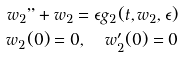<formula> <loc_0><loc_0><loc_500><loc_500>w _ { 2 } " + w _ { 2 } = \epsilon g _ { 2 } ( t , w _ { 2 } , \epsilon ) \\ w _ { 2 } ( 0 ) = 0 , \quad w _ { 2 } ^ { \prime } ( 0 ) = 0</formula> 